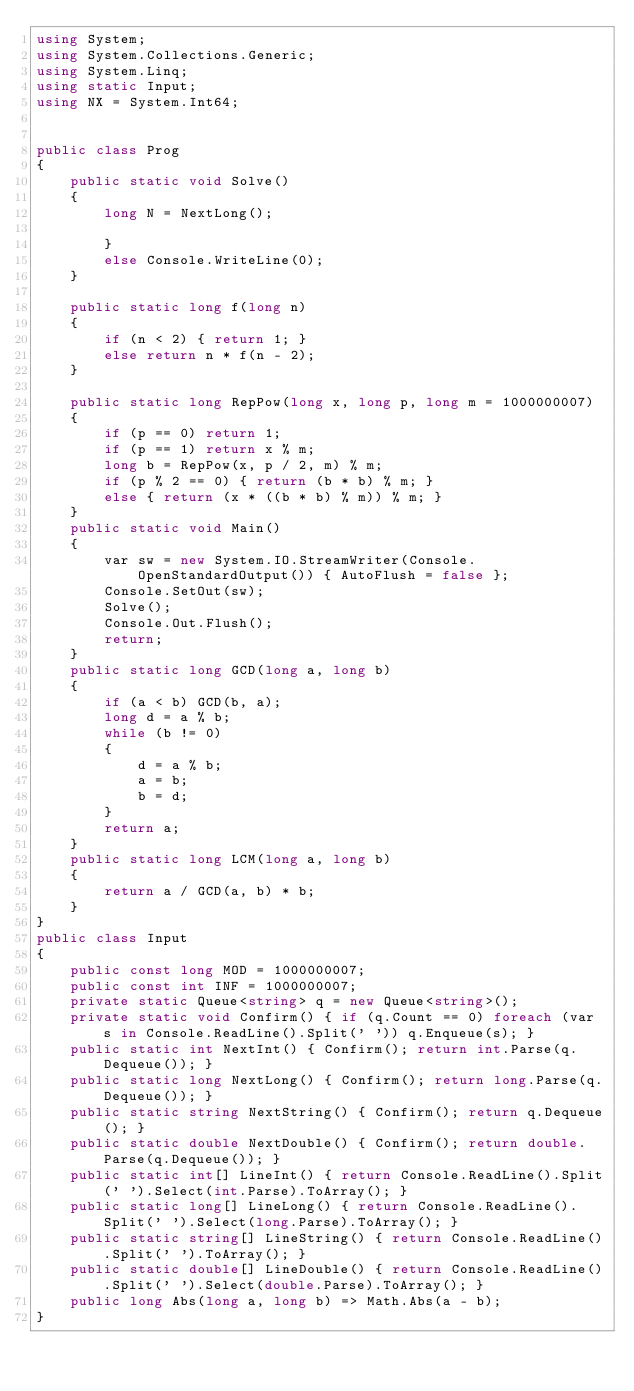Convert code to text. <code><loc_0><loc_0><loc_500><loc_500><_C#_>using System;
using System.Collections.Generic;
using System.Linq;
using static Input;
using NX = System.Int64;


public class Prog
{
    public static void Solve()
    {
        long N = NextLong();
        
        }
        else Console.WriteLine(0);
    }

    public static long f(long n)
    {
        if (n < 2) { return 1; }
        else return n * f(n - 2);
    }

    public static long RepPow(long x, long p, long m = 1000000007)
    {
        if (p == 0) return 1;
        if (p == 1) return x % m;
        long b = RepPow(x, p / 2, m) % m;
        if (p % 2 == 0) { return (b * b) % m; }
        else { return (x * ((b * b) % m)) % m; }
    }
    public static void Main()
    {
        var sw = new System.IO.StreamWriter(Console.OpenStandardOutput()) { AutoFlush = false };
        Console.SetOut(sw);
        Solve();
        Console.Out.Flush();
        return;
    }
    public static long GCD(long a, long b)
    {
        if (a < b) GCD(b, a);
        long d = a % b;
        while (b != 0)
        {
            d = a % b;
            a = b;
            b = d;
        }
        return a;
    }
    public static long LCM(long a, long b)
    {
        return a / GCD(a, b) * b;
    }
}
public class Input
{
    public const long MOD = 1000000007;
    public const int INF = 1000000007;
    private static Queue<string> q = new Queue<string>();
    private static void Confirm() { if (q.Count == 0) foreach (var s in Console.ReadLine().Split(' ')) q.Enqueue(s); }
    public static int NextInt() { Confirm(); return int.Parse(q.Dequeue()); }
    public static long NextLong() { Confirm(); return long.Parse(q.Dequeue()); }
    public static string NextString() { Confirm(); return q.Dequeue(); }
    public static double NextDouble() { Confirm(); return double.Parse(q.Dequeue()); }
    public static int[] LineInt() { return Console.ReadLine().Split(' ').Select(int.Parse).ToArray(); }
    public static long[] LineLong() { return Console.ReadLine().Split(' ').Select(long.Parse).ToArray(); }
    public static string[] LineString() { return Console.ReadLine().Split(' ').ToArray(); }
    public static double[] LineDouble() { return Console.ReadLine().Split(' ').Select(double.Parse).ToArray(); }
    public long Abs(long a, long b) => Math.Abs(a - b);
}
</code> 